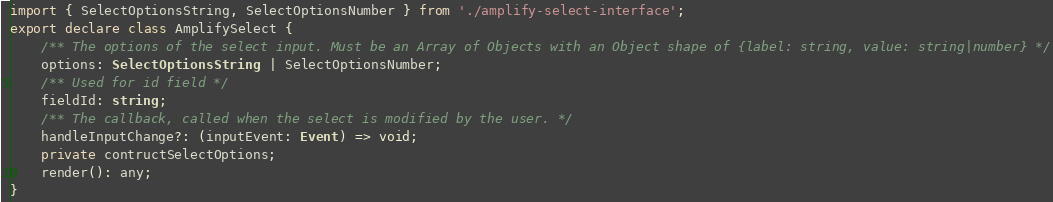<code> <loc_0><loc_0><loc_500><loc_500><_TypeScript_>import { SelectOptionsString, SelectOptionsNumber } from './amplify-select-interface';
export declare class AmplifySelect {
    /** The options of the select input. Must be an Array of Objects with an Object shape of {label: string, value: string|number} */
    options: SelectOptionsString | SelectOptionsNumber;
    /** Used for id field */
    fieldId: string;
    /** The callback, called when the select is modified by the user. */
    handleInputChange?: (inputEvent: Event) => void;
    private contructSelectOptions;
    render(): any;
}
</code> 